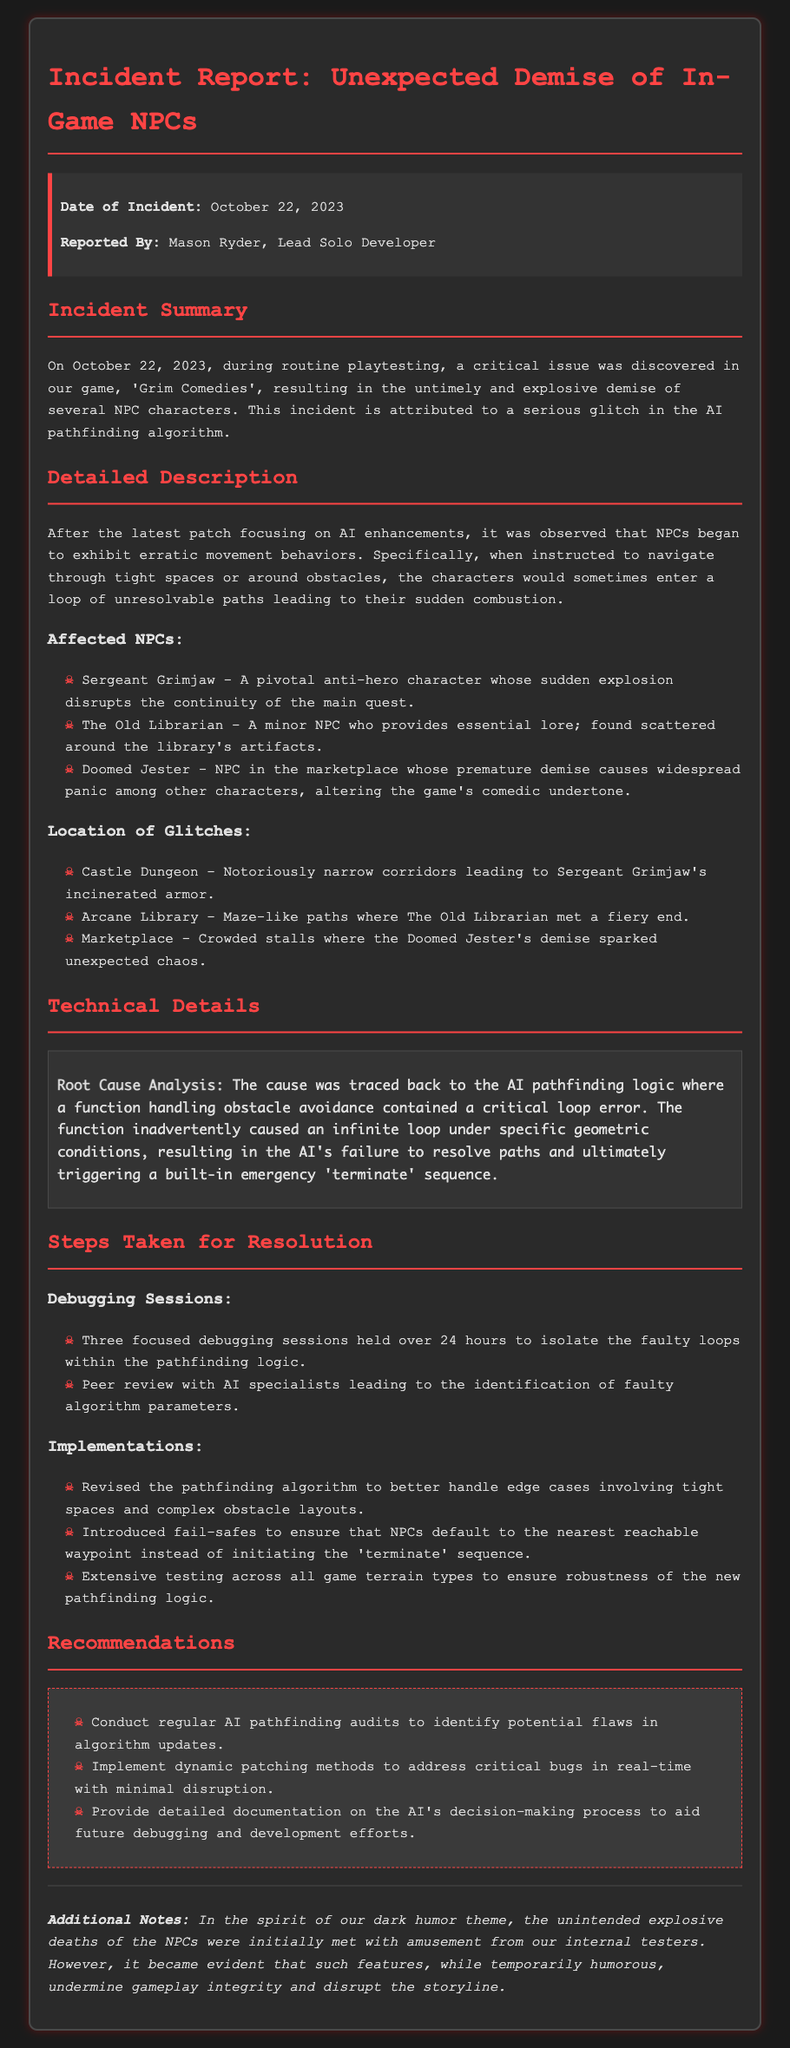What is the date of the incident? The date of the incident is clearly indicated in the document under the incident info section.
Answer: October 22, 2023 Who reported the incident? The name of the person who reported the incident is provided in the incident info section.
Answer: Mason Ryder What is the title of the game involved? The title of the game that experienced the incident is mentioned in the incident summary.
Answer: Grim Comedies How many NPCs were affected? The document lists three specific NPCs affected by the glitch, as detailed in the affected NPCs section.
Answer: Three What was the root cause of the glitch? The specific issue responsible for the NPCs' demise is outlined in the technical details section.
Answer: A critical loop error What location was mentioned for the Doomed Jester's glitch? The specific location where the Doomed Jester experienced the glitch is mentioned in the document.
Answer: Marketplace What type of sessions were held to address the glitch? The document describes the type of sessions conducted to fix the glitch in the pathfinding logic.
Answer: Debugging sessions What recommendation involves audits? One of the recommendations explicitly discusses the need for a specific type of audit pertaining to the AI.
Answer: AI pathfinding audits What is mentioned as an additional note? The document contains a section for additional notes that elaborates on the internal reactions to the NPC deaths.
Answer: Unintended explosive deaths of the NPCs were initially met with amusement 